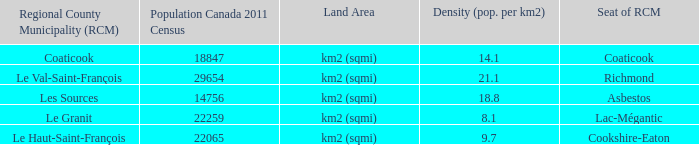What is the seat of the RCM in the county that has a density of 9.7? Cookshire-Eaton. 